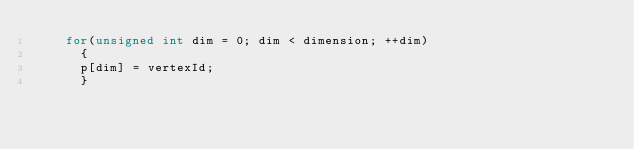Convert code to text. <code><loc_0><loc_0><loc_500><loc_500><_C++_>    for(unsigned int dim = 0; dim < dimension; ++dim)
      {
      p[dim] = vertexId;
      }</code> 